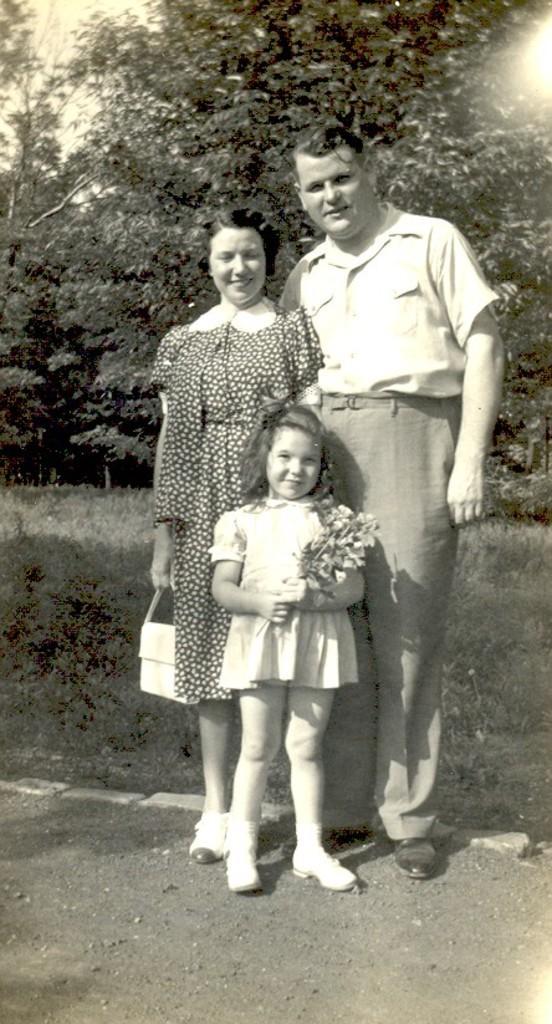Describe this image in one or two sentences. In the middle we can see man, woman and a kid. At the bottom there is soil. In the background we can see plants and trees. 